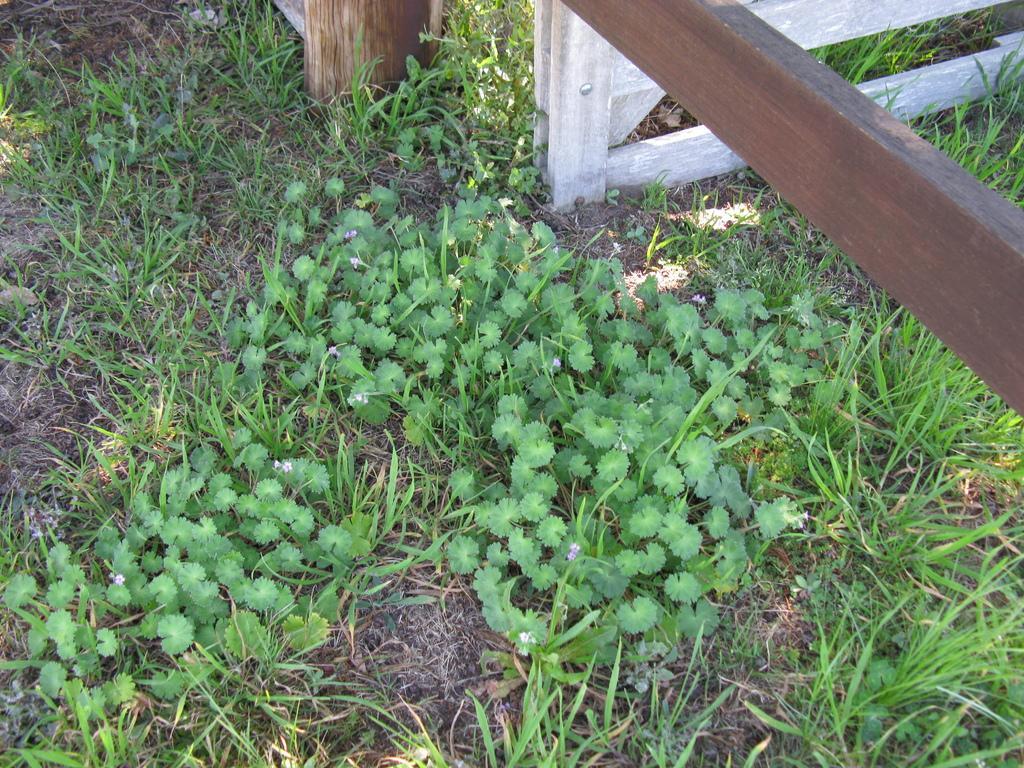Can you describe this image briefly? In this image there are plants on the ground, there is grass, there are wooden objects towards the top of the image, there is a wooden object towards the right of the image. 